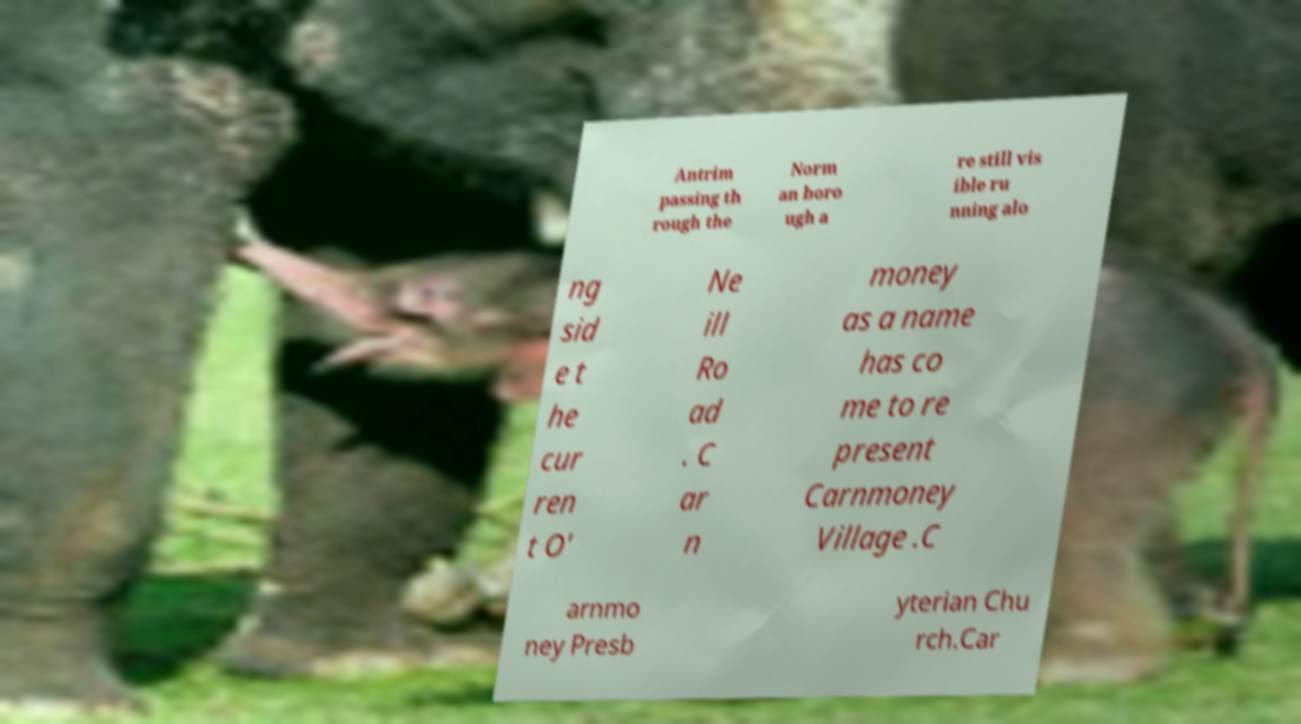Can you accurately transcribe the text from the provided image for me? Antrim passing th rough the Norm an boro ugh a re still vis ible ru nning alo ng sid e t he cur ren t O' Ne ill Ro ad . C ar n money as a name has co me to re present Carnmoney Village .C arnmo ney Presb yterian Chu rch.Car 